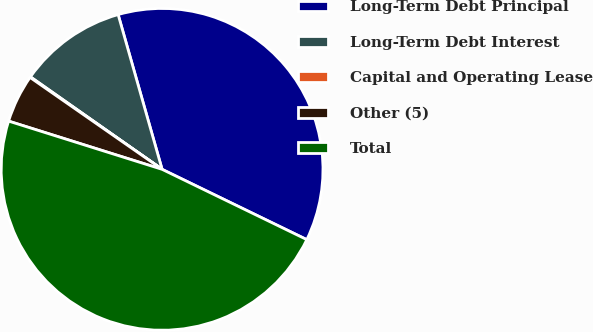Convert chart to OTSL. <chart><loc_0><loc_0><loc_500><loc_500><pie_chart><fcel>Long-Term Debt Principal<fcel>Long-Term Debt Interest<fcel>Capital and Operating Lease<fcel>Other (5)<fcel>Total<nl><fcel>36.6%<fcel>10.85%<fcel>0.07%<fcel>4.83%<fcel>47.65%<nl></chart> 